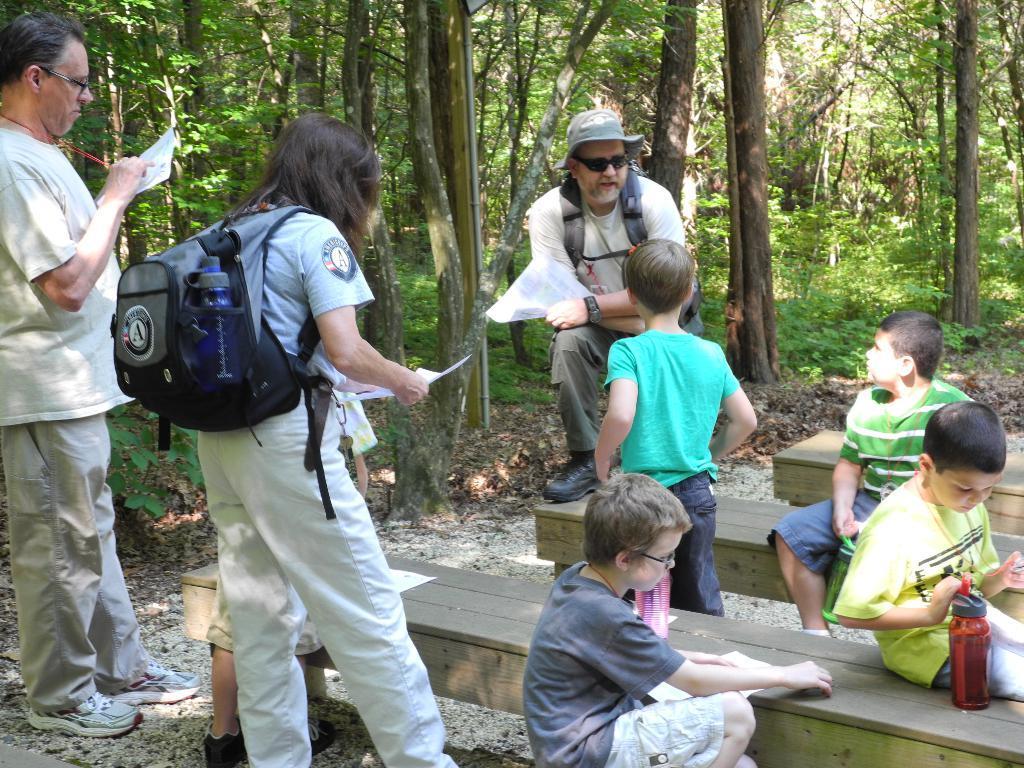How would you summarize this image in a sentence or two? In the center of the image we can see a man is bending and wearing a dress, bag, goggles, hat and holding a paper. On the left side of the image we can see two people are standing and holding the papers and a man is writing by holding a pen and a lady is wearing a bag. At the bottom of the image we can see the ground, benches and some people are sitting on the benches and also we can see a bottle, a boy is standing. At the top of the image we can see the trees, plants and dry leaves. 